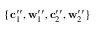<formula> <loc_0><loc_0><loc_500><loc_500>\{ c _ { 1 } ^ { \prime \prime } , w _ { 1 } ^ { \prime \prime } , c _ { 2 } ^ { \prime \prime } , w _ { 2 } ^ { \prime \prime } \}</formula> 